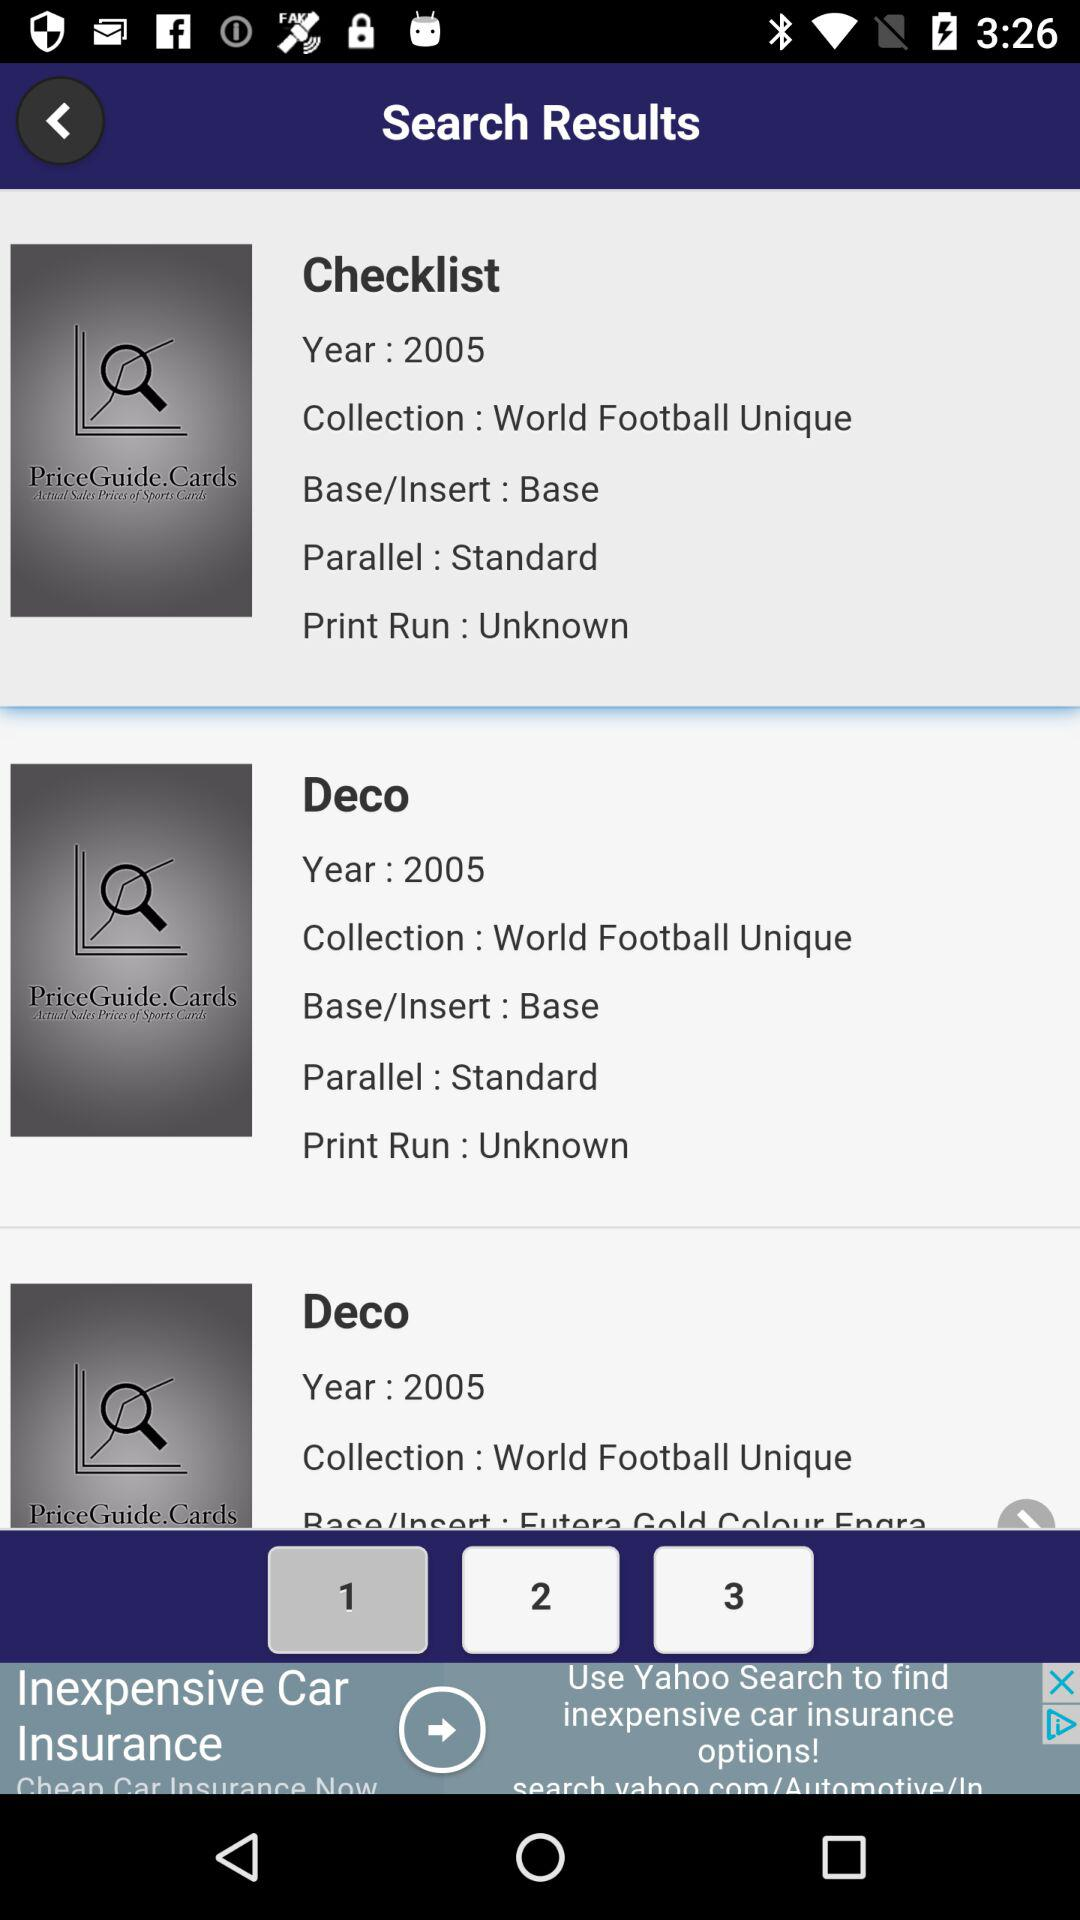How many items are in the search results?
Answer the question using a single word or phrase. 3 